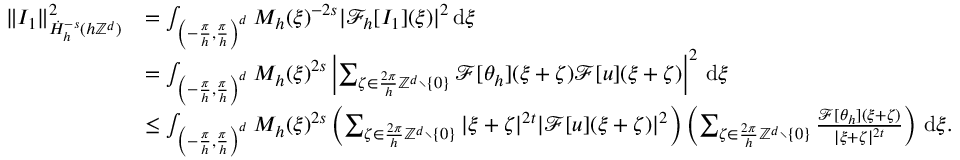<formula> <loc_0><loc_0><loc_500><loc_500>\begin{array} { r l } { \| I _ { 1 } \| _ { \dot { H } _ { h } ^ { - s } ( h \mathbb { Z } ^ { d } ) } ^ { 2 } } & { = \int _ { \left ( - \frac { \pi } { h } , \frac { \pi } { h } \right ) ^ { d } } M _ { h } ( \xi ) ^ { - 2 s } | \mathcal { F } _ { h } [ I _ { 1 } ] ( \xi ) | ^ { 2 } \, d \xi } \\ & { = \int _ { \left ( - \frac { \pi } { h } , \frac { \pi } { h } \right ) ^ { d } } M _ { h } ( \xi ) ^ { 2 s } \left | \sum _ { \zeta \in \frac { 2 \pi } { h } \mathbb { Z } ^ { d } \ \{ 0 \} } \mathcal { F } [ \theta _ { h } ] ( \xi + \zeta ) \mathcal { F } [ u ] ( \xi + \zeta ) \right | ^ { 2 } \, d \xi } \\ & { \leq \int _ { \left ( - \frac { \pi } { h } , \frac { \pi } { h } \right ) ^ { d } } M _ { h } ( \xi ) ^ { 2 s } \left ( \sum _ { \zeta \in \frac { 2 \pi } { h } \mathbb { Z } ^ { d } \ \{ 0 \} } | \xi + \zeta | ^ { 2 t } | \mathcal { F } [ u ] ( \xi + \zeta ) | ^ { 2 } \right ) \left ( \sum _ { \zeta \in \frac { 2 \pi } { h } \mathbb { Z } ^ { d } \ \{ 0 \} } \frac { \mathcal { F } [ \theta _ { h } ] ( \xi + \zeta ) } { | \xi + \zeta | ^ { 2 t } } \right ) \, d \xi . } \end{array}</formula> 